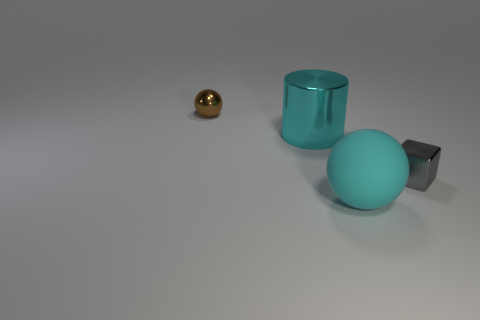How many balls are big things or metallic objects?
Give a very brief answer. 2. What color is the tiny metal thing behind the small thing to the right of the tiny object that is behind the tiny gray shiny cube?
Offer a terse response. Brown. How many other objects are the same size as the cyan cylinder?
Give a very brief answer. 1. Is there anything else that is the same shape as the big metallic object?
Your answer should be very brief. No. What color is the shiny thing that is the same shape as the big matte thing?
Provide a succinct answer. Brown. There is a block that is made of the same material as the large cyan cylinder; what is its color?
Your answer should be compact. Gray. Are there an equal number of small gray objects on the left side of the large metallic cylinder and metal cylinders?
Offer a very short reply. No. Do the metallic thing that is in front of the cylinder and the small brown thing have the same size?
Offer a terse response. Yes. There is another thing that is the same size as the gray thing; what is its color?
Ensure brevity in your answer.  Brown. Is there a small cube that is left of the ball in front of the small thing in front of the tiny brown sphere?
Keep it short and to the point. No. 